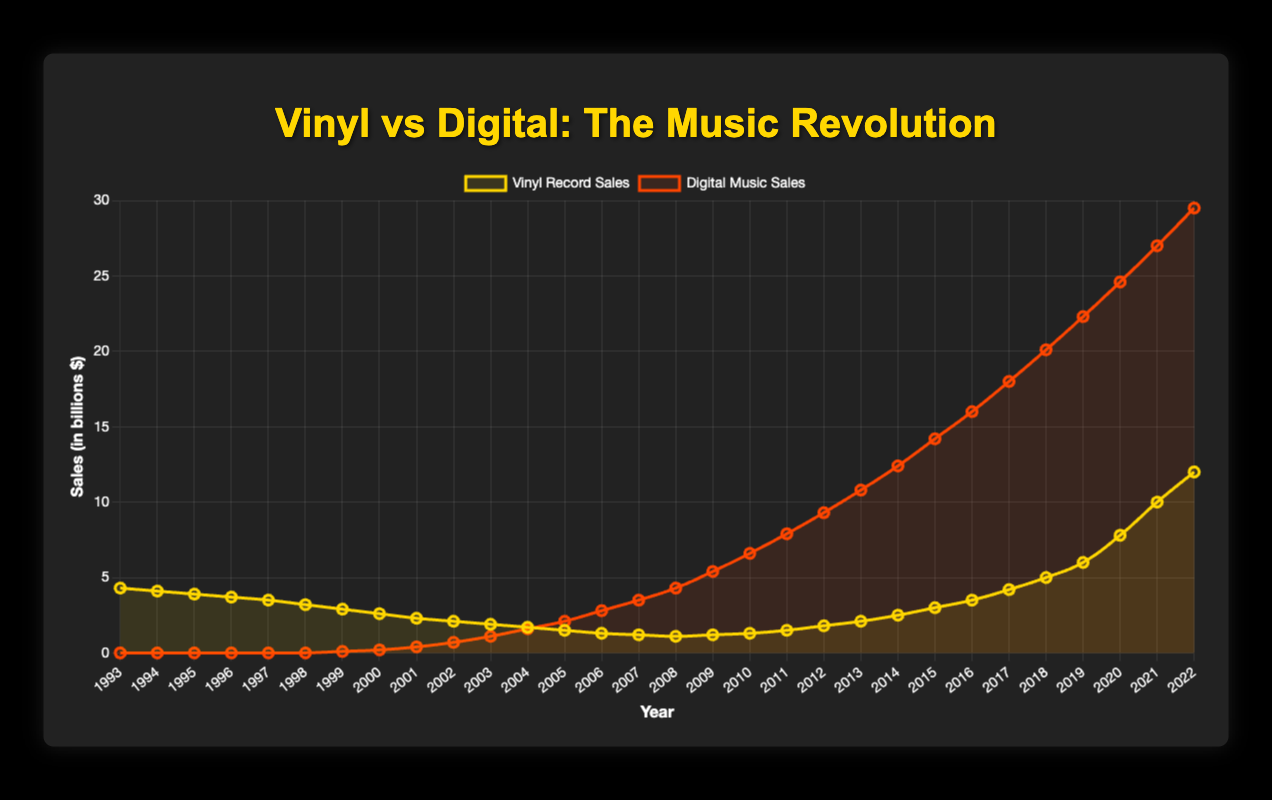What's the trend for vinyl record sales from 1993 to 1999? Vinyl record sales are consistently declining from 4.3 billion in 1993 to 2.9 billion in 1999.
Answer: Declining In 2005, which type of music sales surpassed the other, and by how much? In 2005, digital music sales surpassed vinyl record sales. Digital music sales were 2.1 billion, while vinyl record sales were 1.5 billion, so digital surpassed vinyl by 0.6 billion.
Answer: Digital by 0.6 billion What's the difference in vinyl record sales between 2010 and 2022? In 2010, vinyl record sales were 1.3 billion, and in 2022, they were 12.0 billion. The difference is 12.0 - 1.3 = 10.7 billion.
Answer: 10.7 billion Which year did digital music sales first surpass vinyl record sales? In 2003, digital music sales were 1.1 billion while vinyl record sales were 1.9 billion. In 2004, digital music sales were 1.6 billion, surpassing vinyl record sales of 1.7 billion. Hence, the first year digital surpassed vinyl was 2004.
Answer: 2004 Compare the growth rate of vinyl record sales from 2010 to 2022 with the growth rate of digital music sales from 2000 to 2022. Vinyl record sales grew from 1.3 billion in 2010 to 12.0 billion in 2022. Digital music sales grew from 0.2 billion in 2000 to 29.5 billion in 2022. Vinyl growth rate: (12 - 1.3) / 1.3 ≈ 8.23. Digital growth rate: (29.5 - 0.2) / 0.2 = 146.5.
Answer: Vinyl: 8.2x, Digital: 146.5x Which year did both vinyl and digital sales see simultaneous increases for the first time? The year 2009 shows that both vinyl record sales (1.1 to 1.2 billion) and digital music sales (4.3 to 5.4 billion) see an increase from the previous year.
Answer: 2009 In which year did digital music sales have the highest annual increase? The highest annual increase in digital music sales occurred between 2021 (27.0 billion) and 2022 (29.5 billion), an increase of 2.5 billion.
Answer: 2022 How do the colors and styles differentiate the trends of vinyl and digital music sales in the plot? The plot uses gold for vinyl record sales and red for digital music sales. Vinyl sales are represented by a gold line with tension and points, while digital sales are displayed using a red line with similar attributes.
Answer: Gold for vinyl, red for digital Which 5-year period showed the largest growth in vinyl record sales? From 2017 to 2022, vinyl record sales grew from 4.2 billion to 12.0 billion, a growth of 7.8 billion. This represents the largest 5-year growth period in vinyl sales.
Answer: 2017-2022 